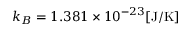Convert formula to latex. <formula><loc_0><loc_0><loc_500><loc_500>k _ { B } = 1 . 3 8 1 \times 1 0 ^ { - 2 3 } [ J / K ]</formula> 